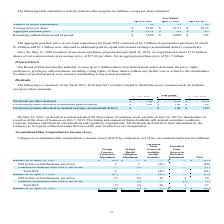According to Netapp's financial document, What did the company declare regarding dividends? a cash dividend of $0.48 per share of common stock, payable on July 24, 2019 to shareholders of record as of the close of business on July 5, 2019.. The document states: "On May 22, 2019, we declared a cash dividend of $0.48 per share of common stock, payable on July 24, 2019 to shareholders of record as of the close of..." Also, Which years does the table provide information for? The document contains multiple relevant values: 2019, 2018, 2017. From the document: "April 26, 2019 April 27, 2018 April 28, 2017 April 26, 2019 April 27, 2018 April 28, 2017 April 26, 2019 April 27, 2018 April 28, 2017..." Also, What do the timing and amount of future dividends depend on? market conditions, corporate business and financial considerations and regulatory requirements.. The document states: "ming and amount of future dividends will depend on market conditions, corporate business and financial considerations and regulatory requirements. All..." Also, can you calculate: What was the change in the Dividends per share declared between 2018 and 2019? Based on the calculation: 1.60-0.80, the result is 0.8. This is based on the information: "Dividends per share declared $ 1.60 $ 0.80 $ 0.76 Dividends per share declared $ 1.60 $ 0.80 $ 0.76..." The key data points involved are: 0.80, 1.60. Also, can you calculate: What was the change in the Dividend payments allocated to retained earnings (accumulated deficit) between 2017 and 2018? Based on the calculation: 108-120, the result is -12 (in millions). This is based on the information: "to retained earnings (accumulated deficit) $ — $ 108 $ 120 tained earnings (accumulated deficit) $ — $ 108 $ 120..." The key data points involved are: 108, 120. Also, can you calculate: What was the percentage change in the Dividend payments allocated to additional paid-in capital between 2017 and 2018? To answer this question, I need to perform calculations using the financial data. The calculation is: (106-88)/88, which equals 20.45 (percentage). This is based on the information: "s allocated to additional paid-in capital $ 403 $ 106 $ 88 cated to additional paid-in capital $ 403 $ 106 $ 88..." The key data points involved are: 106, 88. 